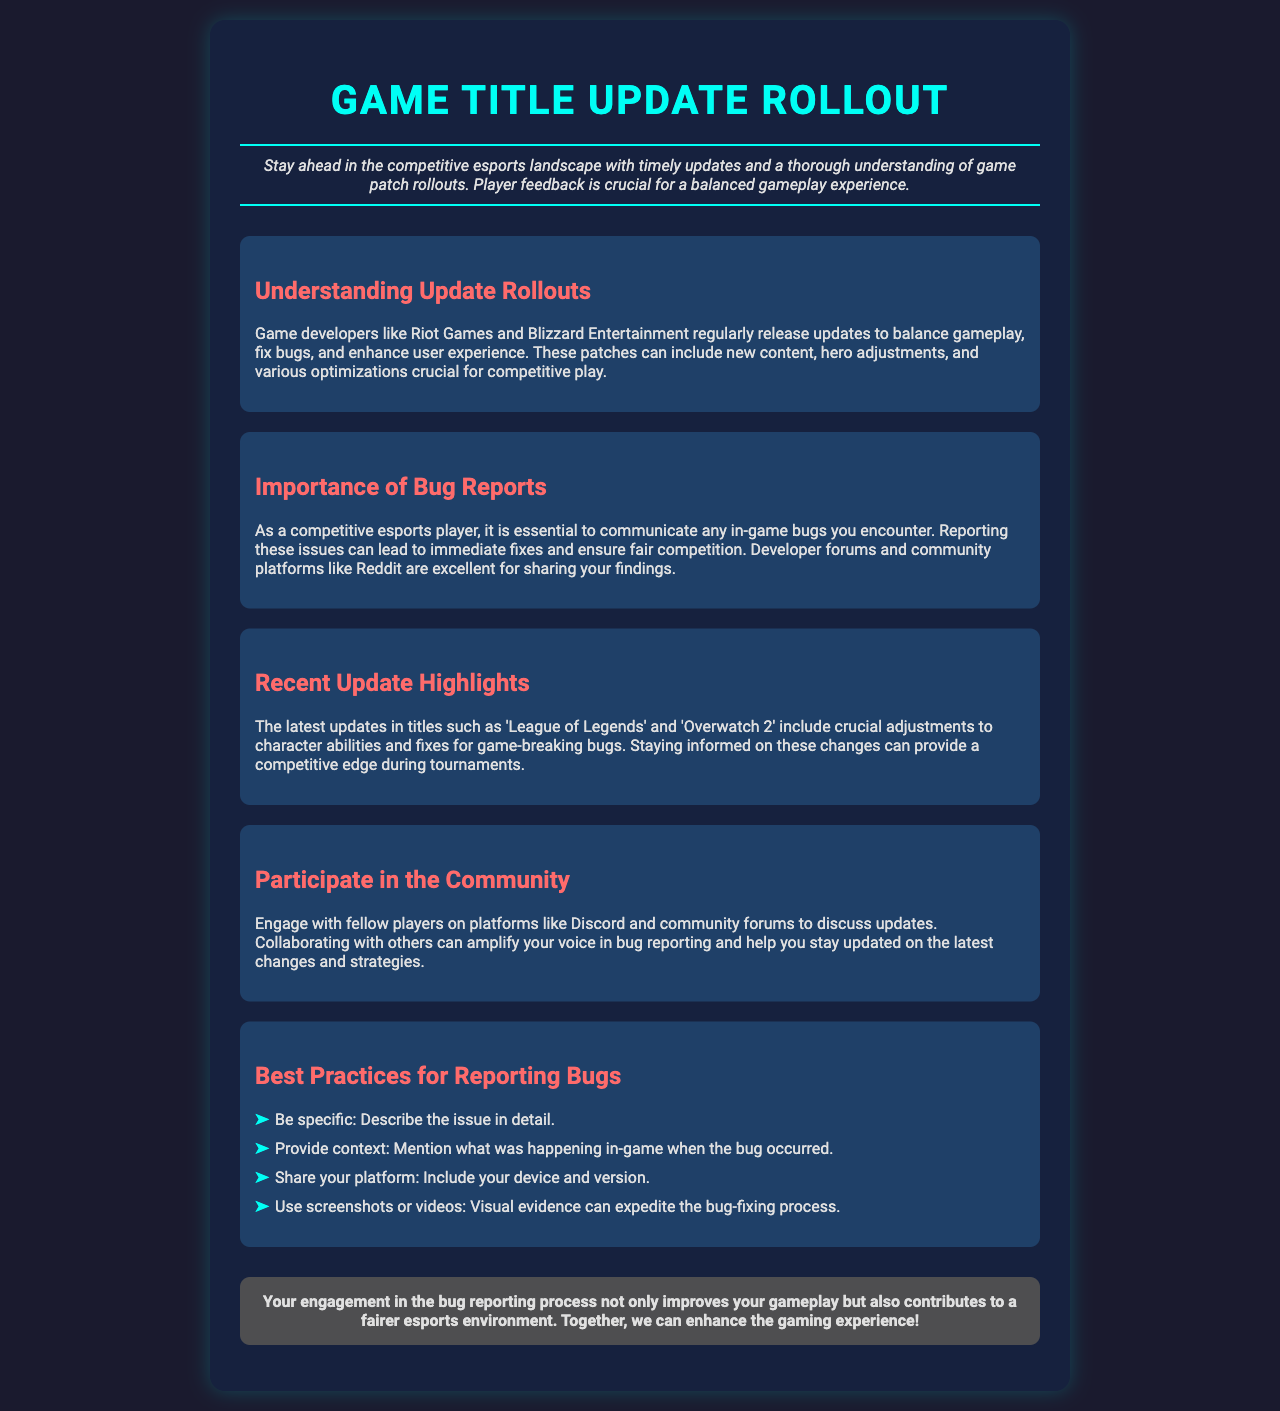What is the title of the document? The title of the document is explicitly mentioned at the top of the brochure.
Answer: Game Title Update Rollout What is emphasized in the introduction? The introduction highlights the importance of updates and player feedback for fair gameplay.
Answer: Player feedback Which game developers are mentioned in the document? The document names specific game developers known for regular updates in the esports industry.
Answer: Riot Games and Blizzard Entertainment What is a key component of bug reporting mentioned? The document suggests a specific approach players should take when reporting bugs.
Answer: Be specific What should you include when reporting a bug? The document states to mention specific information about the in-game context when reporting a bug.
Answer: Context What is an example of a game with recent updates mentioned? The document provides examples of specific games that have had recent patches or updates.
Answer: League of Legends What is a platform for discussion mentioned in the document? The document identifies communication platforms where players can engage with each other about updates.
Answer: Discord In what section is the community engagement discussed? The document has a dedicated section that promotes collaboration among players.
Answer: Participate in the Community What is the conclusion's focus? The conclusion summarizes the main theme of engaging in the bug reporting process and its impact on gameplay.
Answer: Fairer esports environment 